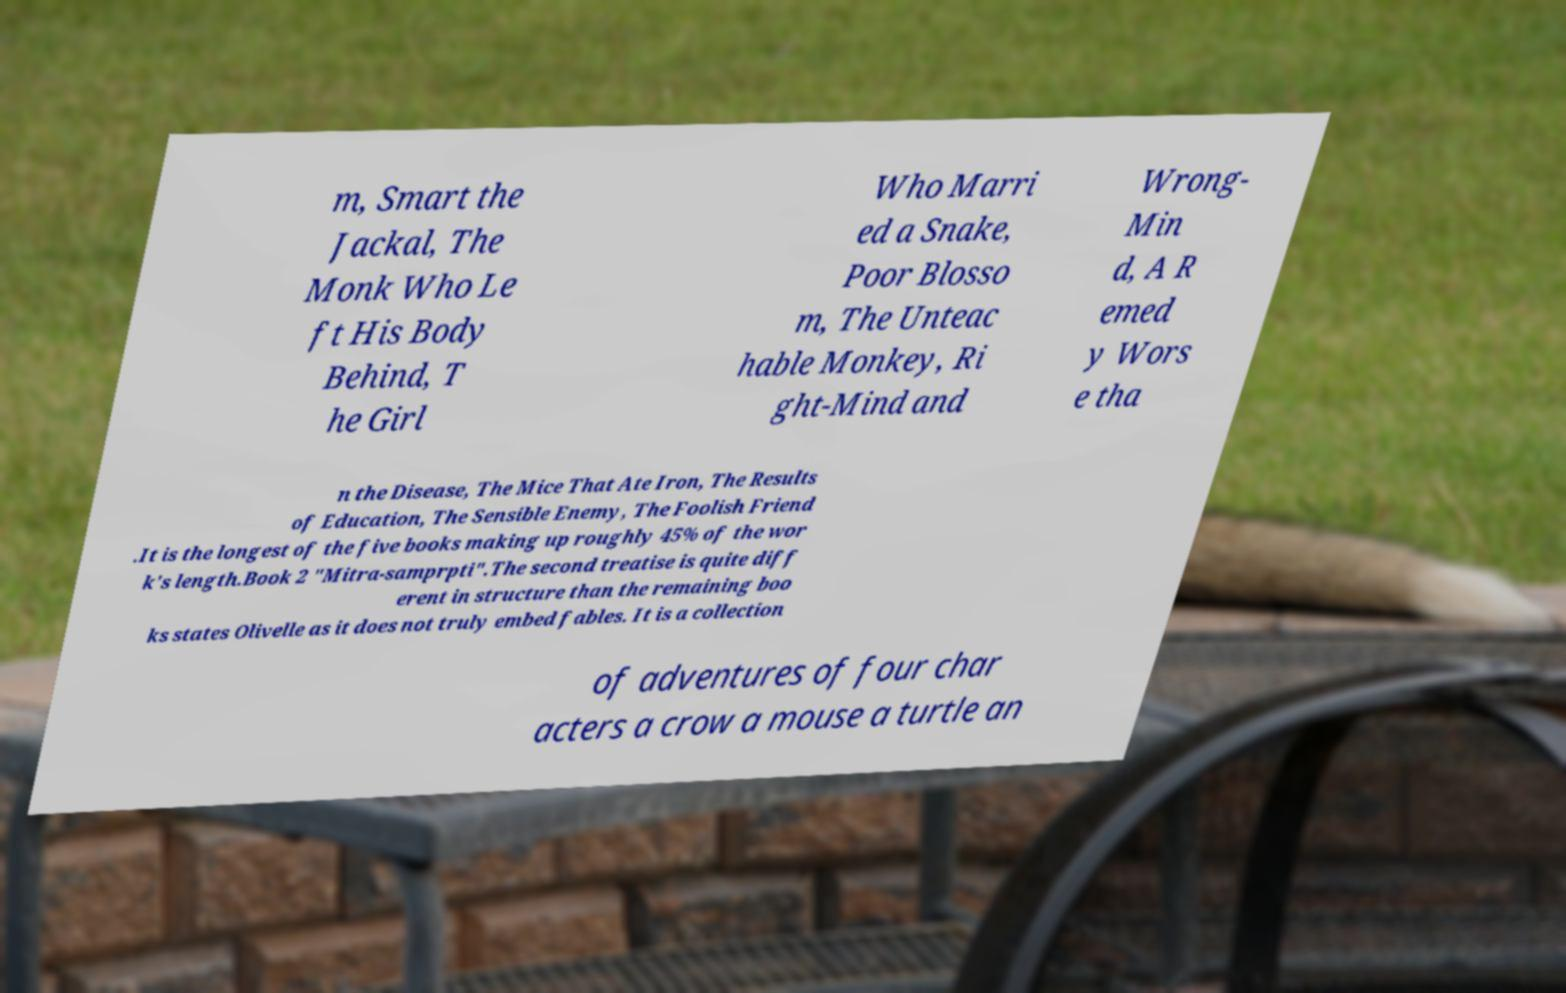I need the written content from this picture converted into text. Can you do that? m, Smart the Jackal, The Monk Who Le ft His Body Behind, T he Girl Who Marri ed a Snake, Poor Blosso m, The Unteac hable Monkey, Ri ght-Mind and Wrong- Min d, A R emed y Wors e tha n the Disease, The Mice That Ate Iron, The Results of Education, The Sensible Enemy, The Foolish Friend .It is the longest of the five books making up roughly 45% of the wor k's length.Book 2 "Mitra-samprpti".The second treatise is quite diff erent in structure than the remaining boo ks states Olivelle as it does not truly embed fables. It is a collection of adventures of four char acters a crow a mouse a turtle an 